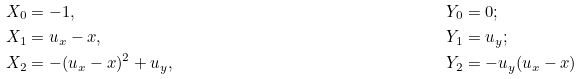Convert formula to latex. <formula><loc_0><loc_0><loc_500><loc_500>X _ { 0 } & = - 1 , & & Y _ { 0 } = 0 ; \\ X _ { 1 } & = u _ { x } - x , & & Y _ { 1 } = u _ { y } ; \\ X _ { 2 } & = - ( u _ { x } - x ) ^ { 2 } + u _ { y } , & & Y _ { 2 } = - u _ { y } ( u _ { x } - x )</formula> 